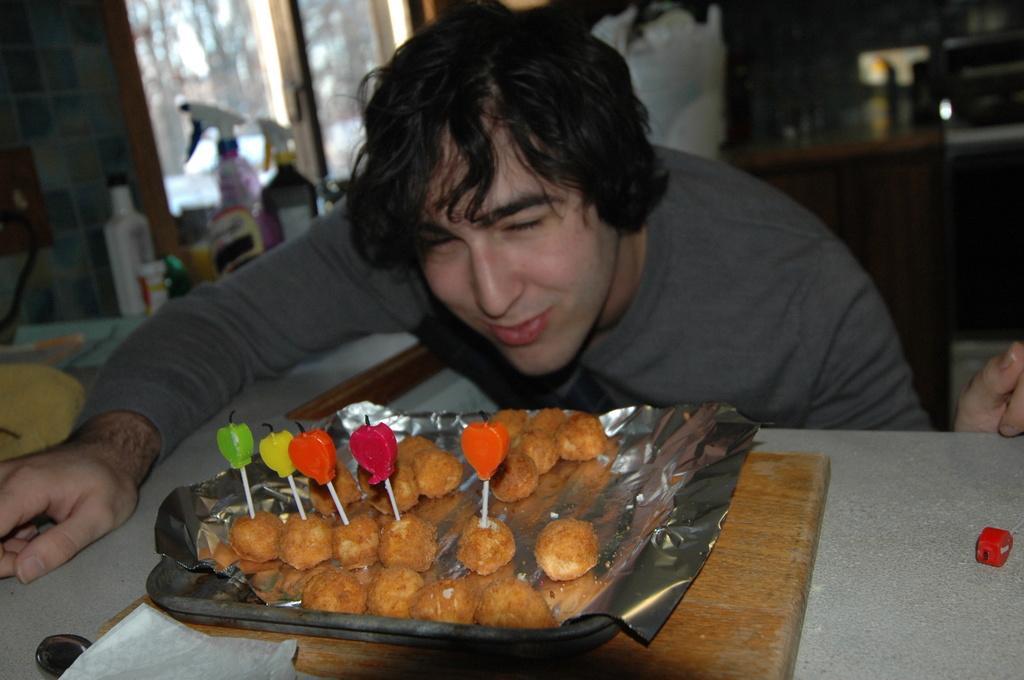Could you give a brief overview of what you see in this image? In this picture we can observe a person wearing a grey color T shirt in front of a table. There is some food places in the plate on the white color table. On the left side there are some bottles placed on the desk. There is a window in the background. 